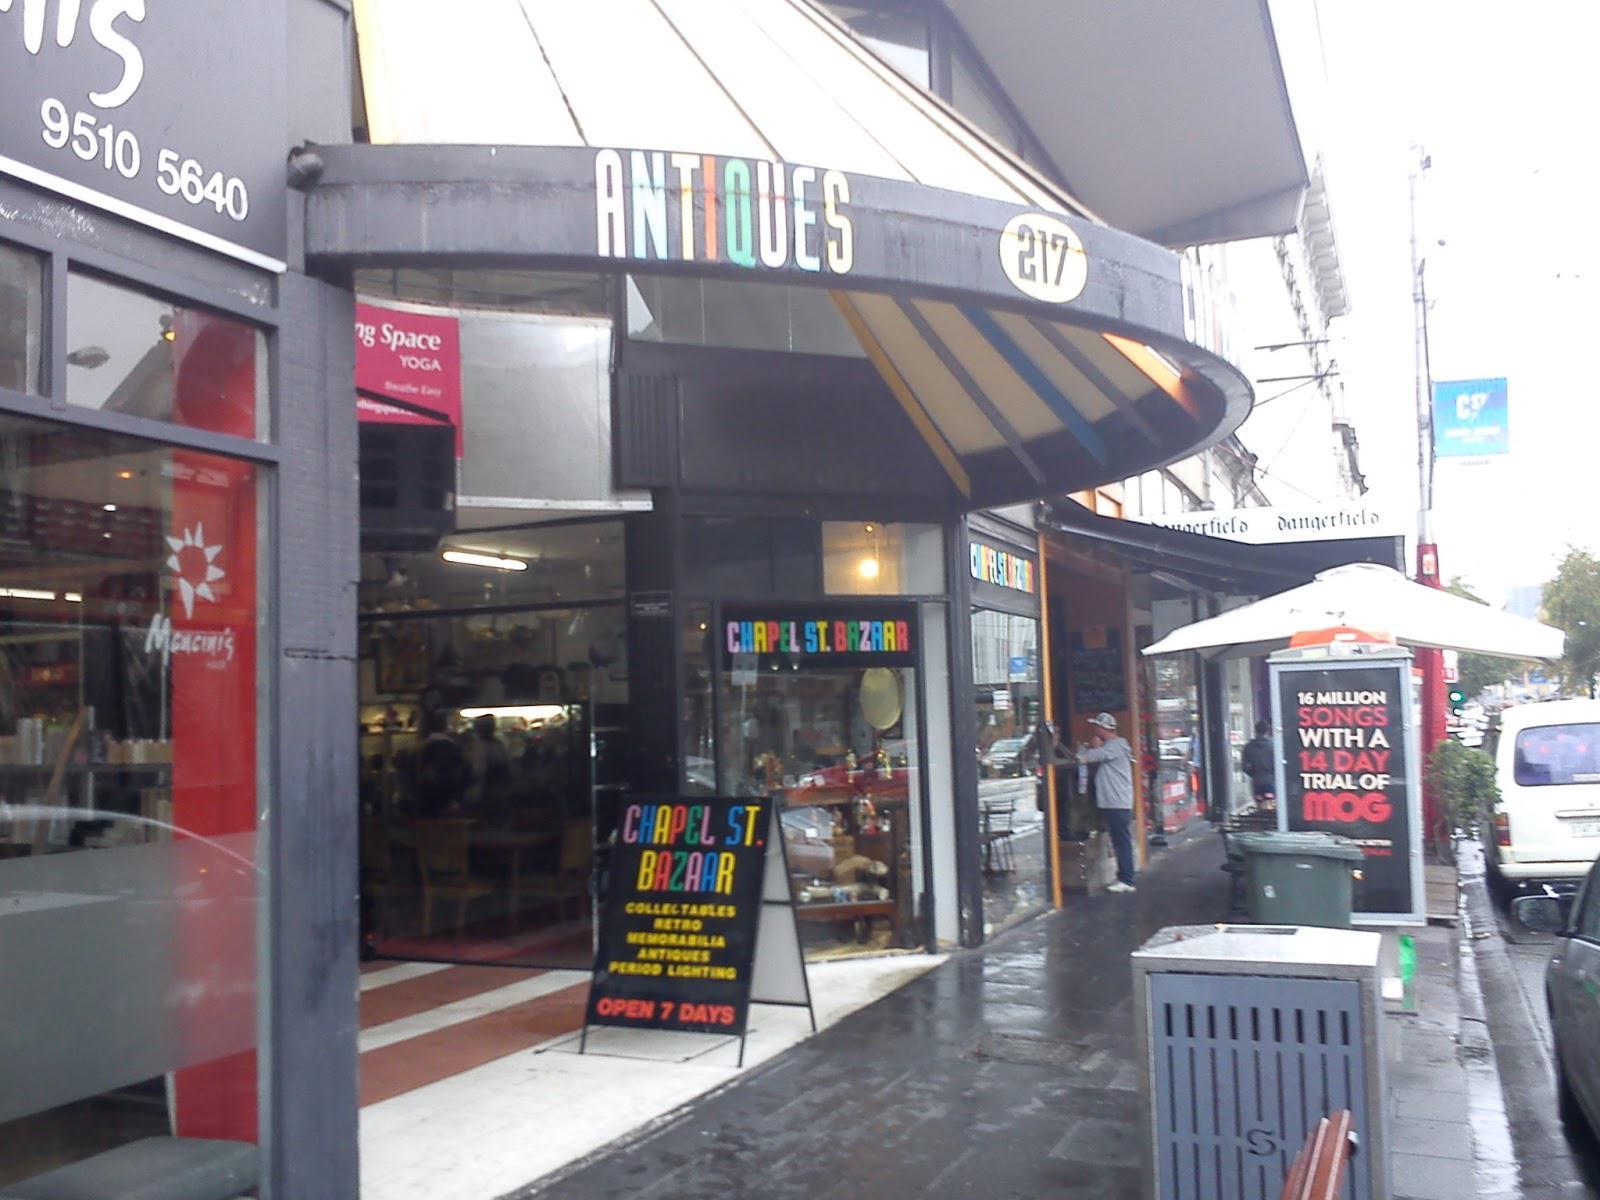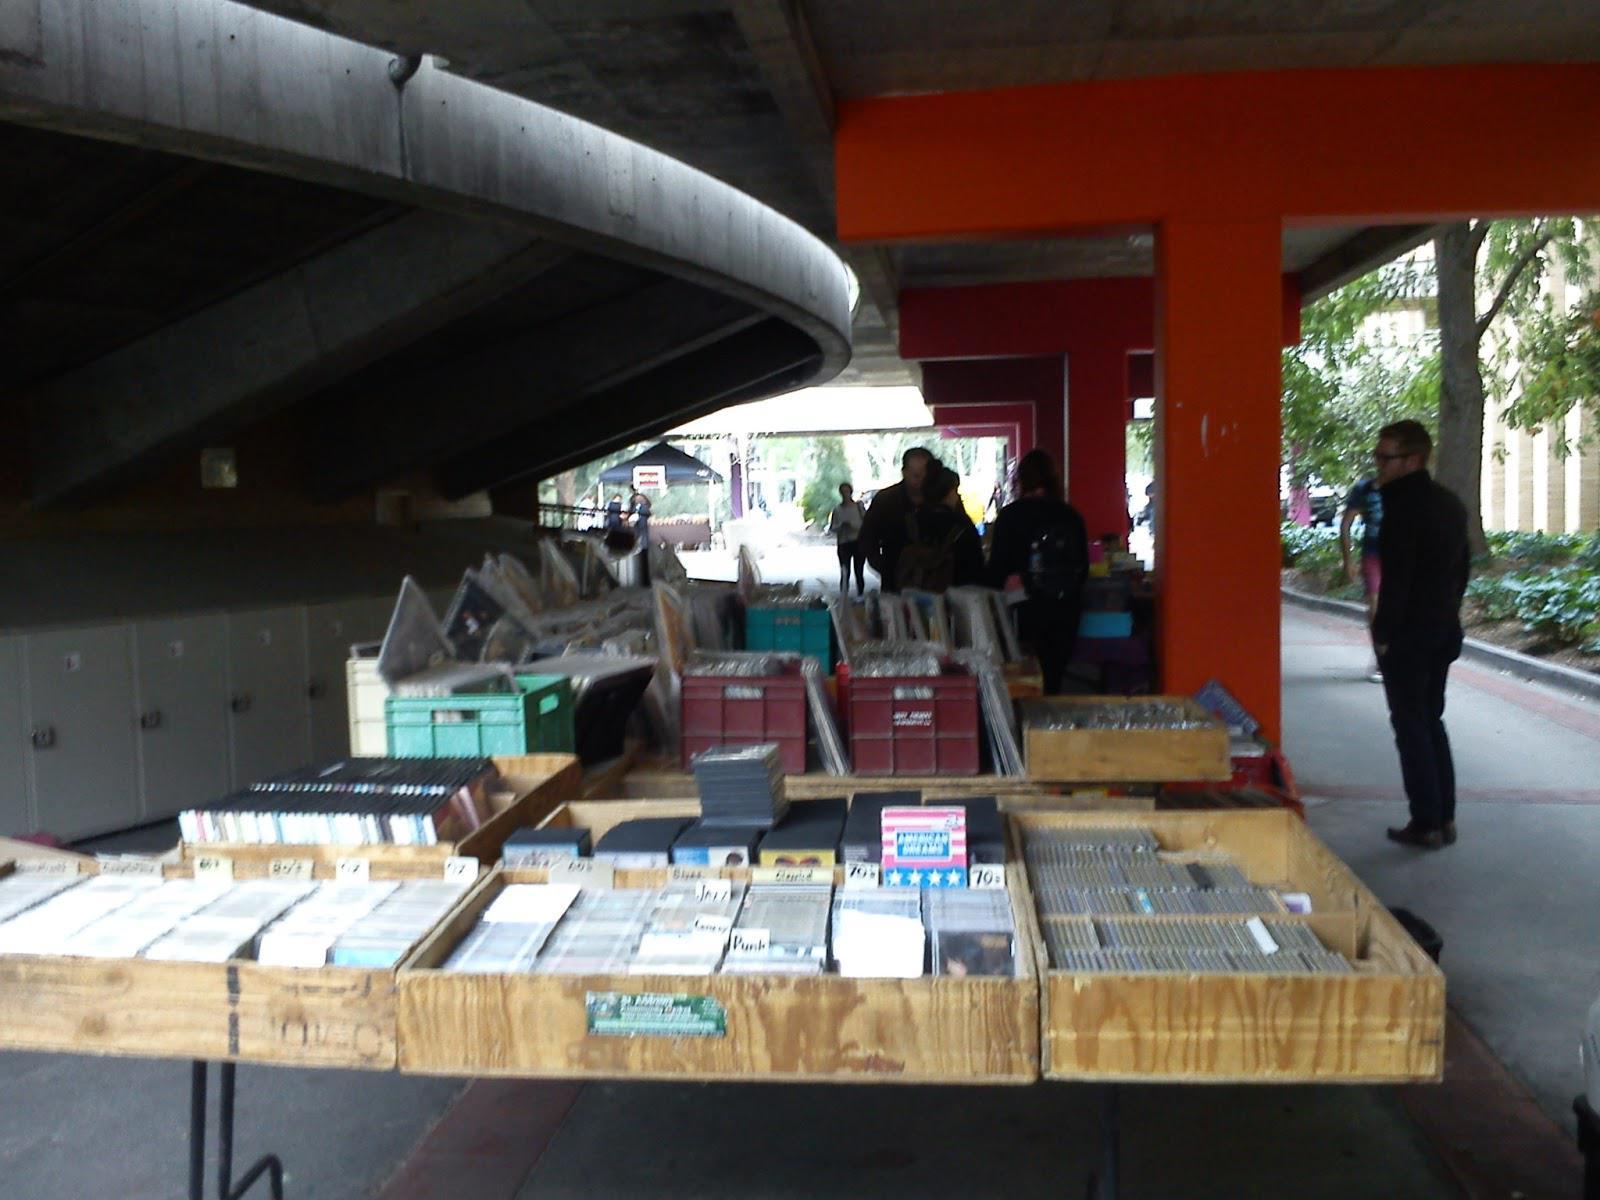The first image is the image on the left, the second image is the image on the right. Evaluate the accuracy of this statement regarding the images: "At least one image shows a person standing in front of a counter and at least one person in a blue shirt behind a counter, with shelves full of books behind that person.". Is it true? Answer yes or no. No. The first image is the image on the left, the second image is the image on the right. Considering the images on both sides, is "A single person is standing out side the book shop in the image on the left." valid? Answer yes or no. Yes. 